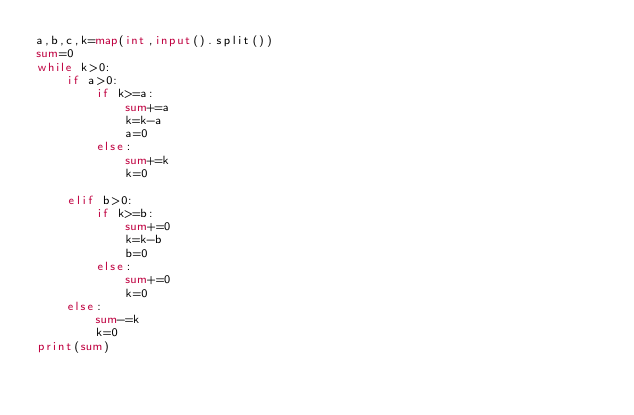<code> <loc_0><loc_0><loc_500><loc_500><_Python_>a,b,c,k=map(int,input().split())
sum=0
while k>0:
    if a>0:
        if k>=a:
            sum+=a
            k=k-a
            a=0
        else:
            sum+=k
            k=0

    elif b>0:
        if k>=b:
            sum+=0
            k=k-b
            b=0
        else:
            sum+=0
            k=0
    else:
        sum-=k
        k=0
print(sum)</code> 